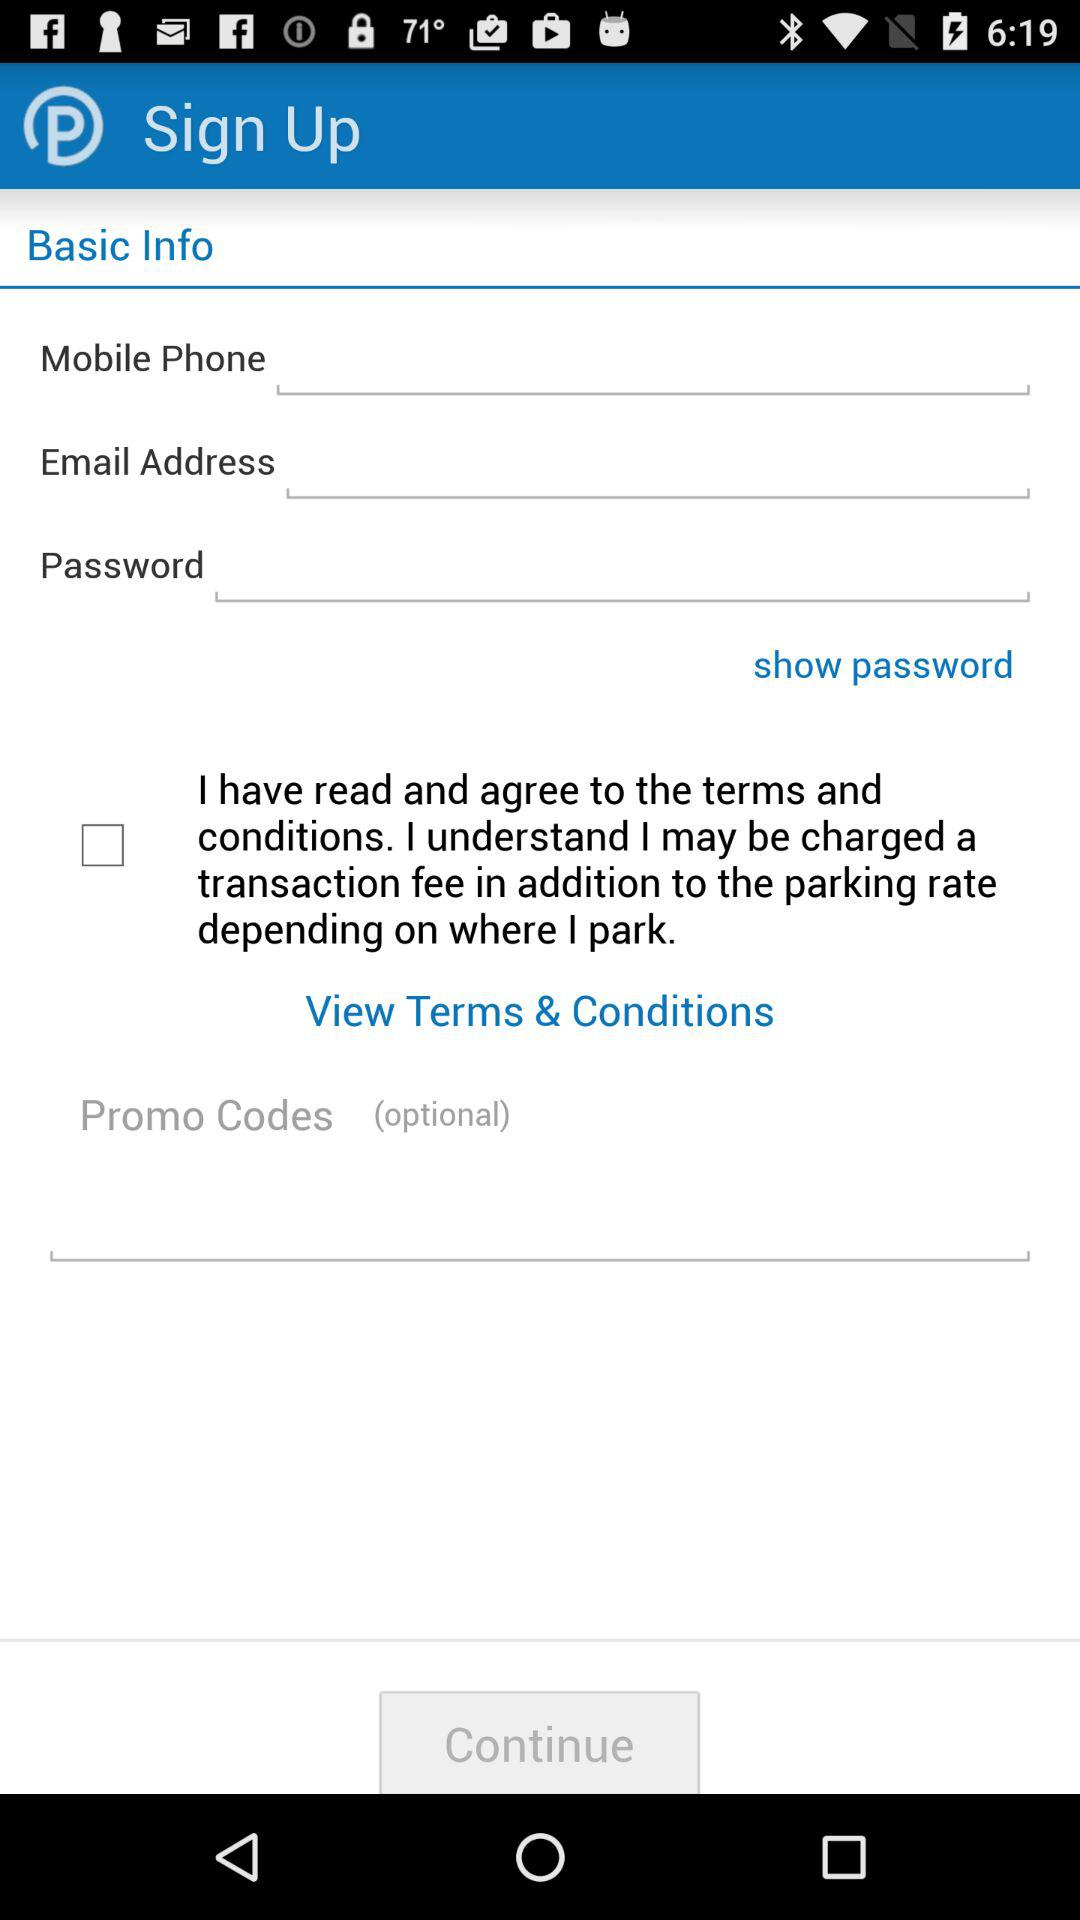What is the status of the view terms & conditions? The status is off. 